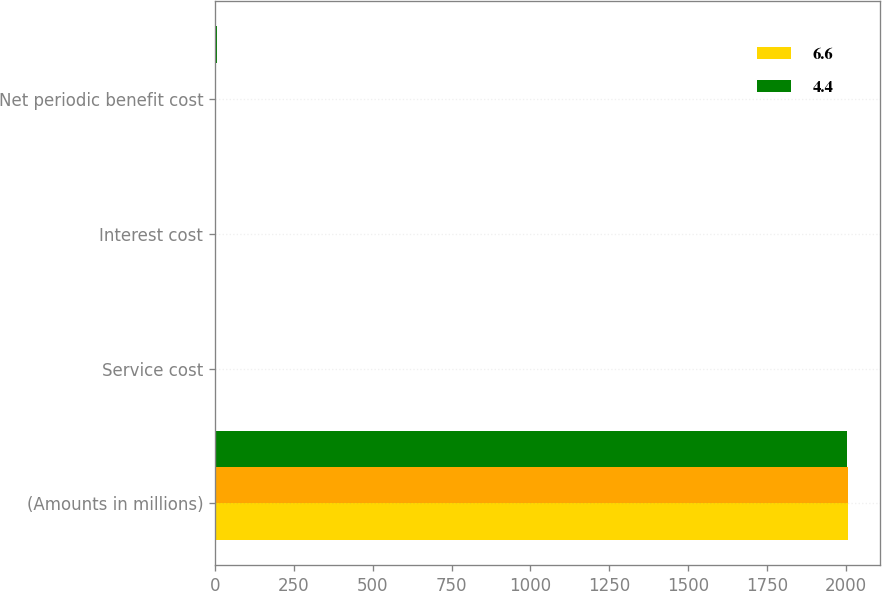Convert chart to OTSL. <chart><loc_0><loc_0><loc_500><loc_500><stacked_bar_chart><ecel><fcel>(Amounts in millions)<fcel>Service cost<fcel>Interest cost<fcel>Net periodic benefit cost<nl><fcel>6.6<fcel>2007<fcel>0.4<fcel>4.3<fcel>3.2<nl><fcel>nan<fcel>2006<fcel>0.5<fcel>4.2<fcel>3.2<nl><fcel>4.4<fcel>2005<fcel>0.7<fcel>4.8<fcel>5.5<nl></chart> 